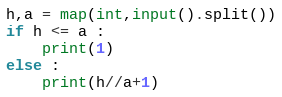<code> <loc_0><loc_0><loc_500><loc_500><_Python_>h,a = map(int,input().split())
if h <= a :
    print(1)
else :
    print(h//a+1)</code> 